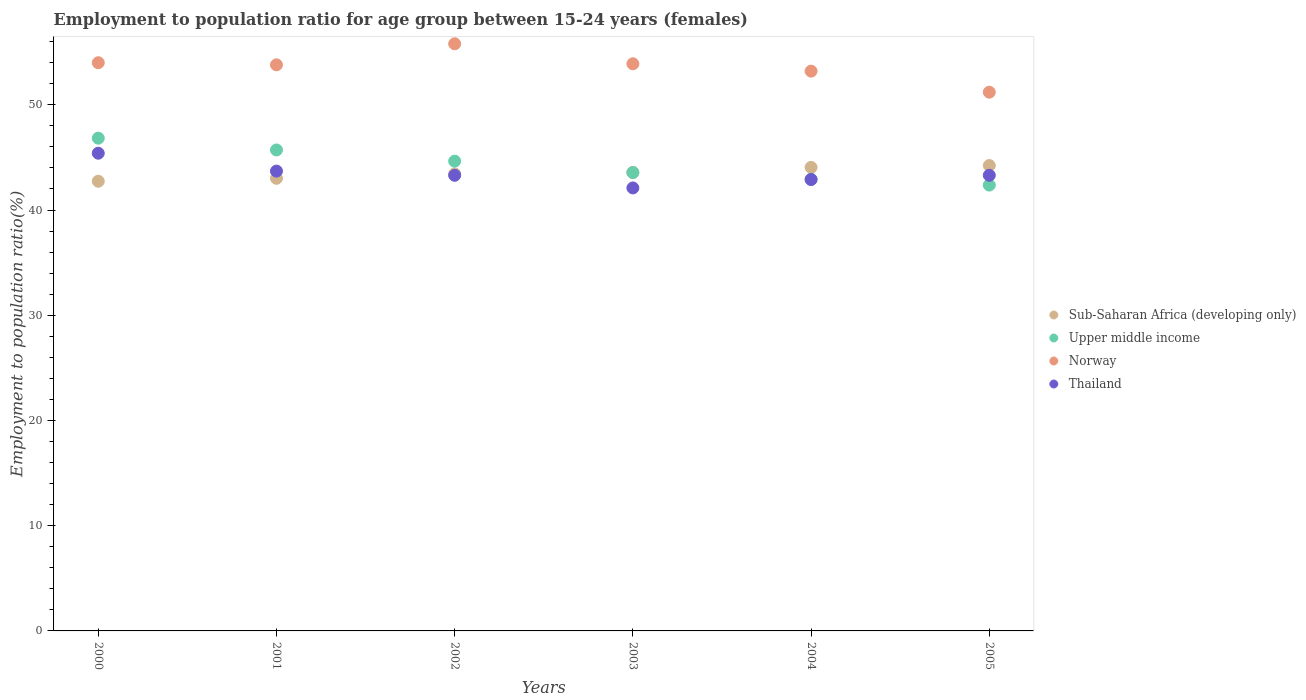What is the employment to population ratio in Sub-Saharan Africa (developing only) in 2003?
Your response must be concise. 43.58. Across all years, what is the maximum employment to population ratio in Norway?
Your answer should be compact. 55.8. Across all years, what is the minimum employment to population ratio in Thailand?
Keep it short and to the point. 42.1. What is the total employment to population ratio in Sub-Saharan Africa (developing only) in the graph?
Make the answer very short. 261.04. What is the difference between the employment to population ratio in Sub-Saharan Africa (developing only) in 2000 and that in 2005?
Keep it short and to the point. -1.49. What is the difference between the employment to population ratio in Norway in 2002 and the employment to population ratio in Upper middle income in 2003?
Offer a very short reply. 12.24. What is the average employment to population ratio in Sub-Saharan Africa (developing only) per year?
Your answer should be compact. 43.51. In the year 2000, what is the difference between the employment to population ratio in Upper middle income and employment to population ratio in Sub-Saharan Africa (developing only)?
Offer a terse response. 4.09. In how many years, is the employment to population ratio in Upper middle income greater than 8 %?
Your answer should be compact. 6. What is the ratio of the employment to population ratio in Thailand in 2003 to that in 2004?
Your response must be concise. 0.98. Is the difference between the employment to population ratio in Upper middle income in 2003 and 2004 greater than the difference between the employment to population ratio in Sub-Saharan Africa (developing only) in 2003 and 2004?
Your response must be concise. Yes. What is the difference between the highest and the second highest employment to population ratio in Norway?
Give a very brief answer. 1.8. What is the difference between the highest and the lowest employment to population ratio in Thailand?
Your answer should be very brief. 3.3. Is it the case that in every year, the sum of the employment to population ratio in Sub-Saharan Africa (developing only) and employment to population ratio in Norway  is greater than the employment to population ratio in Upper middle income?
Provide a short and direct response. Yes. Is the employment to population ratio in Upper middle income strictly greater than the employment to population ratio in Norway over the years?
Give a very brief answer. No. Is the employment to population ratio in Norway strictly less than the employment to population ratio in Sub-Saharan Africa (developing only) over the years?
Ensure brevity in your answer.  No. What is the difference between two consecutive major ticks on the Y-axis?
Provide a succinct answer. 10. Are the values on the major ticks of Y-axis written in scientific E-notation?
Keep it short and to the point. No. Does the graph contain any zero values?
Keep it short and to the point. No. Does the graph contain grids?
Your answer should be compact. No. Where does the legend appear in the graph?
Offer a terse response. Center right. What is the title of the graph?
Make the answer very short. Employment to population ratio for age group between 15-24 years (females). What is the label or title of the X-axis?
Provide a succinct answer. Years. What is the Employment to population ratio(%) in Sub-Saharan Africa (developing only) in 2000?
Your answer should be very brief. 42.74. What is the Employment to population ratio(%) in Upper middle income in 2000?
Make the answer very short. 46.83. What is the Employment to population ratio(%) of Thailand in 2000?
Give a very brief answer. 45.4. What is the Employment to population ratio(%) in Sub-Saharan Africa (developing only) in 2001?
Provide a short and direct response. 43.01. What is the Employment to population ratio(%) in Upper middle income in 2001?
Ensure brevity in your answer.  45.71. What is the Employment to population ratio(%) in Norway in 2001?
Make the answer very short. 53.8. What is the Employment to population ratio(%) in Thailand in 2001?
Provide a short and direct response. 43.7. What is the Employment to population ratio(%) in Sub-Saharan Africa (developing only) in 2002?
Provide a short and direct response. 43.43. What is the Employment to population ratio(%) of Upper middle income in 2002?
Your answer should be compact. 44.65. What is the Employment to population ratio(%) of Norway in 2002?
Offer a very short reply. 55.8. What is the Employment to population ratio(%) of Thailand in 2002?
Ensure brevity in your answer.  43.3. What is the Employment to population ratio(%) of Sub-Saharan Africa (developing only) in 2003?
Offer a terse response. 43.58. What is the Employment to population ratio(%) of Upper middle income in 2003?
Offer a terse response. 43.56. What is the Employment to population ratio(%) in Norway in 2003?
Make the answer very short. 53.9. What is the Employment to population ratio(%) in Thailand in 2003?
Make the answer very short. 42.1. What is the Employment to population ratio(%) of Sub-Saharan Africa (developing only) in 2004?
Offer a very short reply. 44.05. What is the Employment to population ratio(%) of Upper middle income in 2004?
Ensure brevity in your answer.  42.92. What is the Employment to population ratio(%) of Norway in 2004?
Your response must be concise. 53.2. What is the Employment to population ratio(%) of Thailand in 2004?
Your answer should be very brief. 42.9. What is the Employment to population ratio(%) in Sub-Saharan Africa (developing only) in 2005?
Provide a short and direct response. 44.23. What is the Employment to population ratio(%) of Upper middle income in 2005?
Keep it short and to the point. 42.37. What is the Employment to population ratio(%) in Norway in 2005?
Your answer should be compact. 51.2. What is the Employment to population ratio(%) of Thailand in 2005?
Your answer should be compact. 43.3. Across all years, what is the maximum Employment to population ratio(%) in Sub-Saharan Africa (developing only)?
Ensure brevity in your answer.  44.23. Across all years, what is the maximum Employment to population ratio(%) in Upper middle income?
Ensure brevity in your answer.  46.83. Across all years, what is the maximum Employment to population ratio(%) in Norway?
Your response must be concise. 55.8. Across all years, what is the maximum Employment to population ratio(%) of Thailand?
Provide a short and direct response. 45.4. Across all years, what is the minimum Employment to population ratio(%) of Sub-Saharan Africa (developing only)?
Your answer should be compact. 42.74. Across all years, what is the minimum Employment to population ratio(%) of Upper middle income?
Your response must be concise. 42.37. Across all years, what is the minimum Employment to population ratio(%) in Norway?
Offer a very short reply. 51.2. Across all years, what is the minimum Employment to population ratio(%) of Thailand?
Offer a very short reply. 42.1. What is the total Employment to population ratio(%) of Sub-Saharan Africa (developing only) in the graph?
Your answer should be very brief. 261.04. What is the total Employment to population ratio(%) of Upper middle income in the graph?
Provide a short and direct response. 266.04. What is the total Employment to population ratio(%) in Norway in the graph?
Make the answer very short. 321.9. What is the total Employment to population ratio(%) in Thailand in the graph?
Make the answer very short. 260.7. What is the difference between the Employment to population ratio(%) of Sub-Saharan Africa (developing only) in 2000 and that in 2001?
Ensure brevity in your answer.  -0.28. What is the difference between the Employment to population ratio(%) of Upper middle income in 2000 and that in 2001?
Give a very brief answer. 1.12. What is the difference between the Employment to population ratio(%) of Sub-Saharan Africa (developing only) in 2000 and that in 2002?
Provide a succinct answer. -0.7. What is the difference between the Employment to population ratio(%) in Upper middle income in 2000 and that in 2002?
Keep it short and to the point. 2.18. What is the difference between the Employment to population ratio(%) of Thailand in 2000 and that in 2002?
Provide a succinct answer. 2.1. What is the difference between the Employment to population ratio(%) in Sub-Saharan Africa (developing only) in 2000 and that in 2003?
Your response must be concise. -0.84. What is the difference between the Employment to population ratio(%) in Upper middle income in 2000 and that in 2003?
Your answer should be compact. 3.27. What is the difference between the Employment to population ratio(%) in Sub-Saharan Africa (developing only) in 2000 and that in 2004?
Provide a succinct answer. -1.32. What is the difference between the Employment to population ratio(%) in Upper middle income in 2000 and that in 2004?
Your answer should be compact. 3.91. What is the difference between the Employment to population ratio(%) in Sub-Saharan Africa (developing only) in 2000 and that in 2005?
Provide a short and direct response. -1.49. What is the difference between the Employment to population ratio(%) of Upper middle income in 2000 and that in 2005?
Offer a terse response. 4.46. What is the difference between the Employment to population ratio(%) in Sub-Saharan Africa (developing only) in 2001 and that in 2002?
Offer a very short reply. -0.42. What is the difference between the Employment to population ratio(%) of Upper middle income in 2001 and that in 2002?
Offer a terse response. 1.06. What is the difference between the Employment to population ratio(%) of Sub-Saharan Africa (developing only) in 2001 and that in 2003?
Offer a terse response. -0.56. What is the difference between the Employment to population ratio(%) of Upper middle income in 2001 and that in 2003?
Provide a short and direct response. 2.14. What is the difference between the Employment to population ratio(%) of Sub-Saharan Africa (developing only) in 2001 and that in 2004?
Provide a succinct answer. -1.04. What is the difference between the Employment to population ratio(%) in Upper middle income in 2001 and that in 2004?
Give a very brief answer. 2.78. What is the difference between the Employment to population ratio(%) of Norway in 2001 and that in 2004?
Provide a short and direct response. 0.6. What is the difference between the Employment to population ratio(%) in Sub-Saharan Africa (developing only) in 2001 and that in 2005?
Keep it short and to the point. -1.21. What is the difference between the Employment to population ratio(%) in Upper middle income in 2001 and that in 2005?
Keep it short and to the point. 3.34. What is the difference between the Employment to population ratio(%) in Sub-Saharan Africa (developing only) in 2002 and that in 2003?
Your answer should be very brief. -0.14. What is the difference between the Employment to population ratio(%) in Upper middle income in 2002 and that in 2003?
Ensure brevity in your answer.  1.08. What is the difference between the Employment to population ratio(%) in Norway in 2002 and that in 2003?
Make the answer very short. 1.9. What is the difference between the Employment to population ratio(%) in Sub-Saharan Africa (developing only) in 2002 and that in 2004?
Keep it short and to the point. -0.62. What is the difference between the Employment to population ratio(%) of Upper middle income in 2002 and that in 2004?
Provide a short and direct response. 1.72. What is the difference between the Employment to population ratio(%) of Norway in 2002 and that in 2004?
Ensure brevity in your answer.  2.6. What is the difference between the Employment to population ratio(%) in Sub-Saharan Africa (developing only) in 2002 and that in 2005?
Provide a short and direct response. -0.79. What is the difference between the Employment to population ratio(%) of Upper middle income in 2002 and that in 2005?
Make the answer very short. 2.27. What is the difference between the Employment to population ratio(%) in Thailand in 2002 and that in 2005?
Ensure brevity in your answer.  0. What is the difference between the Employment to population ratio(%) of Sub-Saharan Africa (developing only) in 2003 and that in 2004?
Keep it short and to the point. -0.48. What is the difference between the Employment to population ratio(%) of Upper middle income in 2003 and that in 2004?
Provide a short and direct response. 0.64. What is the difference between the Employment to population ratio(%) of Norway in 2003 and that in 2004?
Your answer should be very brief. 0.7. What is the difference between the Employment to population ratio(%) of Sub-Saharan Africa (developing only) in 2003 and that in 2005?
Provide a succinct answer. -0.65. What is the difference between the Employment to population ratio(%) in Upper middle income in 2003 and that in 2005?
Offer a terse response. 1.19. What is the difference between the Employment to population ratio(%) in Norway in 2003 and that in 2005?
Ensure brevity in your answer.  2.7. What is the difference between the Employment to population ratio(%) in Sub-Saharan Africa (developing only) in 2004 and that in 2005?
Your answer should be very brief. -0.17. What is the difference between the Employment to population ratio(%) in Upper middle income in 2004 and that in 2005?
Ensure brevity in your answer.  0.55. What is the difference between the Employment to population ratio(%) in Norway in 2004 and that in 2005?
Your answer should be very brief. 2. What is the difference between the Employment to population ratio(%) in Thailand in 2004 and that in 2005?
Ensure brevity in your answer.  -0.4. What is the difference between the Employment to population ratio(%) of Sub-Saharan Africa (developing only) in 2000 and the Employment to population ratio(%) of Upper middle income in 2001?
Your response must be concise. -2.97. What is the difference between the Employment to population ratio(%) of Sub-Saharan Africa (developing only) in 2000 and the Employment to population ratio(%) of Norway in 2001?
Your answer should be very brief. -11.06. What is the difference between the Employment to population ratio(%) of Sub-Saharan Africa (developing only) in 2000 and the Employment to population ratio(%) of Thailand in 2001?
Ensure brevity in your answer.  -0.96. What is the difference between the Employment to population ratio(%) of Upper middle income in 2000 and the Employment to population ratio(%) of Norway in 2001?
Your response must be concise. -6.97. What is the difference between the Employment to population ratio(%) in Upper middle income in 2000 and the Employment to population ratio(%) in Thailand in 2001?
Your answer should be compact. 3.13. What is the difference between the Employment to population ratio(%) in Norway in 2000 and the Employment to population ratio(%) in Thailand in 2001?
Offer a terse response. 10.3. What is the difference between the Employment to population ratio(%) of Sub-Saharan Africa (developing only) in 2000 and the Employment to population ratio(%) of Upper middle income in 2002?
Offer a terse response. -1.91. What is the difference between the Employment to population ratio(%) of Sub-Saharan Africa (developing only) in 2000 and the Employment to population ratio(%) of Norway in 2002?
Give a very brief answer. -13.06. What is the difference between the Employment to population ratio(%) of Sub-Saharan Africa (developing only) in 2000 and the Employment to population ratio(%) of Thailand in 2002?
Offer a very short reply. -0.56. What is the difference between the Employment to population ratio(%) in Upper middle income in 2000 and the Employment to population ratio(%) in Norway in 2002?
Offer a terse response. -8.97. What is the difference between the Employment to population ratio(%) in Upper middle income in 2000 and the Employment to population ratio(%) in Thailand in 2002?
Ensure brevity in your answer.  3.53. What is the difference between the Employment to population ratio(%) in Norway in 2000 and the Employment to population ratio(%) in Thailand in 2002?
Offer a terse response. 10.7. What is the difference between the Employment to population ratio(%) of Sub-Saharan Africa (developing only) in 2000 and the Employment to population ratio(%) of Upper middle income in 2003?
Keep it short and to the point. -0.83. What is the difference between the Employment to population ratio(%) of Sub-Saharan Africa (developing only) in 2000 and the Employment to population ratio(%) of Norway in 2003?
Keep it short and to the point. -11.16. What is the difference between the Employment to population ratio(%) in Sub-Saharan Africa (developing only) in 2000 and the Employment to population ratio(%) in Thailand in 2003?
Offer a very short reply. 0.64. What is the difference between the Employment to population ratio(%) of Upper middle income in 2000 and the Employment to population ratio(%) of Norway in 2003?
Give a very brief answer. -7.07. What is the difference between the Employment to population ratio(%) in Upper middle income in 2000 and the Employment to population ratio(%) in Thailand in 2003?
Provide a short and direct response. 4.73. What is the difference between the Employment to population ratio(%) in Sub-Saharan Africa (developing only) in 2000 and the Employment to population ratio(%) in Upper middle income in 2004?
Your response must be concise. -0.19. What is the difference between the Employment to population ratio(%) in Sub-Saharan Africa (developing only) in 2000 and the Employment to population ratio(%) in Norway in 2004?
Your answer should be compact. -10.46. What is the difference between the Employment to population ratio(%) of Sub-Saharan Africa (developing only) in 2000 and the Employment to population ratio(%) of Thailand in 2004?
Offer a very short reply. -0.16. What is the difference between the Employment to population ratio(%) of Upper middle income in 2000 and the Employment to population ratio(%) of Norway in 2004?
Give a very brief answer. -6.37. What is the difference between the Employment to population ratio(%) of Upper middle income in 2000 and the Employment to population ratio(%) of Thailand in 2004?
Provide a short and direct response. 3.93. What is the difference between the Employment to population ratio(%) in Sub-Saharan Africa (developing only) in 2000 and the Employment to population ratio(%) in Upper middle income in 2005?
Keep it short and to the point. 0.37. What is the difference between the Employment to population ratio(%) in Sub-Saharan Africa (developing only) in 2000 and the Employment to population ratio(%) in Norway in 2005?
Ensure brevity in your answer.  -8.46. What is the difference between the Employment to population ratio(%) of Sub-Saharan Africa (developing only) in 2000 and the Employment to population ratio(%) of Thailand in 2005?
Your answer should be very brief. -0.56. What is the difference between the Employment to population ratio(%) in Upper middle income in 2000 and the Employment to population ratio(%) in Norway in 2005?
Provide a succinct answer. -4.37. What is the difference between the Employment to population ratio(%) of Upper middle income in 2000 and the Employment to population ratio(%) of Thailand in 2005?
Offer a terse response. 3.53. What is the difference between the Employment to population ratio(%) of Norway in 2000 and the Employment to population ratio(%) of Thailand in 2005?
Ensure brevity in your answer.  10.7. What is the difference between the Employment to population ratio(%) of Sub-Saharan Africa (developing only) in 2001 and the Employment to population ratio(%) of Upper middle income in 2002?
Offer a very short reply. -1.63. What is the difference between the Employment to population ratio(%) in Sub-Saharan Africa (developing only) in 2001 and the Employment to population ratio(%) in Norway in 2002?
Your answer should be very brief. -12.79. What is the difference between the Employment to population ratio(%) in Sub-Saharan Africa (developing only) in 2001 and the Employment to population ratio(%) in Thailand in 2002?
Offer a very short reply. -0.29. What is the difference between the Employment to population ratio(%) in Upper middle income in 2001 and the Employment to population ratio(%) in Norway in 2002?
Give a very brief answer. -10.09. What is the difference between the Employment to population ratio(%) in Upper middle income in 2001 and the Employment to population ratio(%) in Thailand in 2002?
Offer a terse response. 2.41. What is the difference between the Employment to population ratio(%) in Norway in 2001 and the Employment to population ratio(%) in Thailand in 2002?
Ensure brevity in your answer.  10.5. What is the difference between the Employment to population ratio(%) of Sub-Saharan Africa (developing only) in 2001 and the Employment to population ratio(%) of Upper middle income in 2003?
Offer a terse response. -0.55. What is the difference between the Employment to population ratio(%) in Sub-Saharan Africa (developing only) in 2001 and the Employment to population ratio(%) in Norway in 2003?
Your answer should be compact. -10.89. What is the difference between the Employment to population ratio(%) of Sub-Saharan Africa (developing only) in 2001 and the Employment to population ratio(%) of Thailand in 2003?
Offer a terse response. 0.91. What is the difference between the Employment to population ratio(%) in Upper middle income in 2001 and the Employment to population ratio(%) in Norway in 2003?
Your answer should be very brief. -8.19. What is the difference between the Employment to population ratio(%) of Upper middle income in 2001 and the Employment to population ratio(%) of Thailand in 2003?
Ensure brevity in your answer.  3.61. What is the difference between the Employment to population ratio(%) of Sub-Saharan Africa (developing only) in 2001 and the Employment to population ratio(%) of Upper middle income in 2004?
Ensure brevity in your answer.  0.09. What is the difference between the Employment to population ratio(%) in Sub-Saharan Africa (developing only) in 2001 and the Employment to population ratio(%) in Norway in 2004?
Your answer should be very brief. -10.19. What is the difference between the Employment to population ratio(%) of Sub-Saharan Africa (developing only) in 2001 and the Employment to population ratio(%) of Thailand in 2004?
Give a very brief answer. 0.11. What is the difference between the Employment to population ratio(%) in Upper middle income in 2001 and the Employment to population ratio(%) in Norway in 2004?
Provide a succinct answer. -7.49. What is the difference between the Employment to population ratio(%) of Upper middle income in 2001 and the Employment to population ratio(%) of Thailand in 2004?
Provide a short and direct response. 2.81. What is the difference between the Employment to population ratio(%) in Norway in 2001 and the Employment to population ratio(%) in Thailand in 2004?
Offer a terse response. 10.9. What is the difference between the Employment to population ratio(%) in Sub-Saharan Africa (developing only) in 2001 and the Employment to population ratio(%) in Upper middle income in 2005?
Make the answer very short. 0.64. What is the difference between the Employment to population ratio(%) in Sub-Saharan Africa (developing only) in 2001 and the Employment to population ratio(%) in Norway in 2005?
Keep it short and to the point. -8.19. What is the difference between the Employment to population ratio(%) in Sub-Saharan Africa (developing only) in 2001 and the Employment to population ratio(%) in Thailand in 2005?
Your answer should be compact. -0.29. What is the difference between the Employment to population ratio(%) of Upper middle income in 2001 and the Employment to population ratio(%) of Norway in 2005?
Ensure brevity in your answer.  -5.49. What is the difference between the Employment to population ratio(%) in Upper middle income in 2001 and the Employment to population ratio(%) in Thailand in 2005?
Ensure brevity in your answer.  2.41. What is the difference between the Employment to population ratio(%) of Sub-Saharan Africa (developing only) in 2002 and the Employment to population ratio(%) of Upper middle income in 2003?
Offer a terse response. -0.13. What is the difference between the Employment to population ratio(%) of Sub-Saharan Africa (developing only) in 2002 and the Employment to population ratio(%) of Norway in 2003?
Keep it short and to the point. -10.47. What is the difference between the Employment to population ratio(%) of Sub-Saharan Africa (developing only) in 2002 and the Employment to population ratio(%) of Thailand in 2003?
Offer a very short reply. 1.33. What is the difference between the Employment to population ratio(%) in Upper middle income in 2002 and the Employment to population ratio(%) in Norway in 2003?
Make the answer very short. -9.25. What is the difference between the Employment to population ratio(%) of Upper middle income in 2002 and the Employment to population ratio(%) of Thailand in 2003?
Ensure brevity in your answer.  2.55. What is the difference between the Employment to population ratio(%) in Norway in 2002 and the Employment to population ratio(%) in Thailand in 2003?
Provide a succinct answer. 13.7. What is the difference between the Employment to population ratio(%) in Sub-Saharan Africa (developing only) in 2002 and the Employment to population ratio(%) in Upper middle income in 2004?
Provide a short and direct response. 0.51. What is the difference between the Employment to population ratio(%) in Sub-Saharan Africa (developing only) in 2002 and the Employment to population ratio(%) in Norway in 2004?
Ensure brevity in your answer.  -9.77. What is the difference between the Employment to population ratio(%) in Sub-Saharan Africa (developing only) in 2002 and the Employment to population ratio(%) in Thailand in 2004?
Your answer should be compact. 0.53. What is the difference between the Employment to population ratio(%) in Upper middle income in 2002 and the Employment to population ratio(%) in Norway in 2004?
Keep it short and to the point. -8.55. What is the difference between the Employment to population ratio(%) in Upper middle income in 2002 and the Employment to population ratio(%) in Thailand in 2004?
Ensure brevity in your answer.  1.75. What is the difference between the Employment to population ratio(%) in Norway in 2002 and the Employment to population ratio(%) in Thailand in 2004?
Offer a terse response. 12.9. What is the difference between the Employment to population ratio(%) in Sub-Saharan Africa (developing only) in 2002 and the Employment to population ratio(%) in Upper middle income in 2005?
Offer a very short reply. 1.06. What is the difference between the Employment to population ratio(%) in Sub-Saharan Africa (developing only) in 2002 and the Employment to population ratio(%) in Norway in 2005?
Ensure brevity in your answer.  -7.77. What is the difference between the Employment to population ratio(%) of Sub-Saharan Africa (developing only) in 2002 and the Employment to population ratio(%) of Thailand in 2005?
Give a very brief answer. 0.13. What is the difference between the Employment to population ratio(%) in Upper middle income in 2002 and the Employment to population ratio(%) in Norway in 2005?
Give a very brief answer. -6.55. What is the difference between the Employment to population ratio(%) of Upper middle income in 2002 and the Employment to population ratio(%) of Thailand in 2005?
Your response must be concise. 1.35. What is the difference between the Employment to population ratio(%) in Sub-Saharan Africa (developing only) in 2003 and the Employment to population ratio(%) in Upper middle income in 2004?
Give a very brief answer. 0.65. What is the difference between the Employment to population ratio(%) of Sub-Saharan Africa (developing only) in 2003 and the Employment to population ratio(%) of Norway in 2004?
Make the answer very short. -9.62. What is the difference between the Employment to population ratio(%) of Sub-Saharan Africa (developing only) in 2003 and the Employment to population ratio(%) of Thailand in 2004?
Offer a terse response. 0.68. What is the difference between the Employment to population ratio(%) in Upper middle income in 2003 and the Employment to population ratio(%) in Norway in 2004?
Provide a succinct answer. -9.64. What is the difference between the Employment to population ratio(%) of Upper middle income in 2003 and the Employment to population ratio(%) of Thailand in 2004?
Ensure brevity in your answer.  0.66. What is the difference between the Employment to population ratio(%) of Sub-Saharan Africa (developing only) in 2003 and the Employment to population ratio(%) of Upper middle income in 2005?
Provide a short and direct response. 1.2. What is the difference between the Employment to population ratio(%) of Sub-Saharan Africa (developing only) in 2003 and the Employment to population ratio(%) of Norway in 2005?
Provide a short and direct response. -7.62. What is the difference between the Employment to population ratio(%) in Sub-Saharan Africa (developing only) in 2003 and the Employment to population ratio(%) in Thailand in 2005?
Ensure brevity in your answer.  0.28. What is the difference between the Employment to population ratio(%) in Upper middle income in 2003 and the Employment to population ratio(%) in Norway in 2005?
Ensure brevity in your answer.  -7.64. What is the difference between the Employment to population ratio(%) of Upper middle income in 2003 and the Employment to population ratio(%) of Thailand in 2005?
Provide a short and direct response. 0.26. What is the difference between the Employment to population ratio(%) in Norway in 2003 and the Employment to population ratio(%) in Thailand in 2005?
Offer a terse response. 10.6. What is the difference between the Employment to population ratio(%) in Sub-Saharan Africa (developing only) in 2004 and the Employment to population ratio(%) in Upper middle income in 2005?
Give a very brief answer. 1.68. What is the difference between the Employment to population ratio(%) of Sub-Saharan Africa (developing only) in 2004 and the Employment to population ratio(%) of Norway in 2005?
Give a very brief answer. -7.15. What is the difference between the Employment to population ratio(%) of Sub-Saharan Africa (developing only) in 2004 and the Employment to population ratio(%) of Thailand in 2005?
Provide a succinct answer. 0.75. What is the difference between the Employment to population ratio(%) in Upper middle income in 2004 and the Employment to population ratio(%) in Norway in 2005?
Give a very brief answer. -8.28. What is the difference between the Employment to population ratio(%) in Upper middle income in 2004 and the Employment to population ratio(%) in Thailand in 2005?
Make the answer very short. -0.38. What is the difference between the Employment to population ratio(%) in Norway in 2004 and the Employment to population ratio(%) in Thailand in 2005?
Provide a short and direct response. 9.9. What is the average Employment to population ratio(%) of Sub-Saharan Africa (developing only) per year?
Your answer should be very brief. 43.51. What is the average Employment to population ratio(%) of Upper middle income per year?
Provide a short and direct response. 44.34. What is the average Employment to population ratio(%) in Norway per year?
Make the answer very short. 53.65. What is the average Employment to population ratio(%) in Thailand per year?
Your answer should be very brief. 43.45. In the year 2000, what is the difference between the Employment to population ratio(%) of Sub-Saharan Africa (developing only) and Employment to population ratio(%) of Upper middle income?
Provide a succinct answer. -4.09. In the year 2000, what is the difference between the Employment to population ratio(%) of Sub-Saharan Africa (developing only) and Employment to population ratio(%) of Norway?
Keep it short and to the point. -11.26. In the year 2000, what is the difference between the Employment to population ratio(%) of Sub-Saharan Africa (developing only) and Employment to population ratio(%) of Thailand?
Keep it short and to the point. -2.66. In the year 2000, what is the difference between the Employment to population ratio(%) in Upper middle income and Employment to population ratio(%) in Norway?
Keep it short and to the point. -7.17. In the year 2000, what is the difference between the Employment to population ratio(%) in Upper middle income and Employment to population ratio(%) in Thailand?
Provide a succinct answer. 1.43. In the year 2000, what is the difference between the Employment to population ratio(%) of Norway and Employment to population ratio(%) of Thailand?
Make the answer very short. 8.6. In the year 2001, what is the difference between the Employment to population ratio(%) of Sub-Saharan Africa (developing only) and Employment to population ratio(%) of Upper middle income?
Your response must be concise. -2.69. In the year 2001, what is the difference between the Employment to population ratio(%) in Sub-Saharan Africa (developing only) and Employment to population ratio(%) in Norway?
Your answer should be compact. -10.79. In the year 2001, what is the difference between the Employment to population ratio(%) in Sub-Saharan Africa (developing only) and Employment to population ratio(%) in Thailand?
Your response must be concise. -0.69. In the year 2001, what is the difference between the Employment to population ratio(%) of Upper middle income and Employment to population ratio(%) of Norway?
Make the answer very short. -8.09. In the year 2001, what is the difference between the Employment to population ratio(%) in Upper middle income and Employment to population ratio(%) in Thailand?
Provide a succinct answer. 2.01. In the year 2001, what is the difference between the Employment to population ratio(%) in Norway and Employment to population ratio(%) in Thailand?
Give a very brief answer. 10.1. In the year 2002, what is the difference between the Employment to population ratio(%) of Sub-Saharan Africa (developing only) and Employment to population ratio(%) of Upper middle income?
Provide a succinct answer. -1.21. In the year 2002, what is the difference between the Employment to population ratio(%) of Sub-Saharan Africa (developing only) and Employment to population ratio(%) of Norway?
Provide a short and direct response. -12.37. In the year 2002, what is the difference between the Employment to population ratio(%) of Sub-Saharan Africa (developing only) and Employment to population ratio(%) of Thailand?
Ensure brevity in your answer.  0.13. In the year 2002, what is the difference between the Employment to population ratio(%) in Upper middle income and Employment to population ratio(%) in Norway?
Make the answer very short. -11.15. In the year 2002, what is the difference between the Employment to population ratio(%) of Upper middle income and Employment to population ratio(%) of Thailand?
Provide a short and direct response. 1.35. In the year 2003, what is the difference between the Employment to population ratio(%) of Sub-Saharan Africa (developing only) and Employment to population ratio(%) of Upper middle income?
Your answer should be compact. 0.01. In the year 2003, what is the difference between the Employment to population ratio(%) in Sub-Saharan Africa (developing only) and Employment to population ratio(%) in Norway?
Your answer should be compact. -10.32. In the year 2003, what is the difference between the Employment to population ratio(%) of Sub-Saharan Africa (developing only) and Employment to population ratio(%) of Thailand?
Ensure brevity in your answer.  1.48. In the year 2003, what is the difference between the Employment to population ratio(%) in Upper middle income and Employment to population ratio(%) in Norway?
Provide a short and direct response. -10.34. In the year 2003, what is the difference between the Employment to population ratio(%) in Upper middle income and Employment to population ratio(%) in Thailand?
Your answer should be very brief. 1.46. In the year 2003, what is the difference between the Employment to population ratio(%) of Norway and Employment to population ratio(%) of Thailand?
Give a very brief answer. 11.8. In the year 2004, what is the difference between the Employment to population ratio(%) in Sub-Saharan Africa (developing only) and Employment to population ratio(%) in Upper middle income?
Provide a succinct answer. 1.13. In the year 2004, what is the difference between the Employment to population ratio(%) of Sub-Saharan Africa (developing only) and Employment to population ratio(%) of Norway?
Give a very brief answer. -9.15. In the year 2004, what is the difference between the Employment to population ratio(%) in Sub-Saharan Africa (developing only) and Employment to population ratio(%) in Thailand?
Your response must be concise. 1.15. In the year 2004, what is the difference between the Employment to population ratio(%) in Upper middle income and Employment to population ratio(%) in Norway?
Make the answer very short. -10.28. In the year 2004, what is the difference between the Employment to population ratio(%) in Upper middle income and Employment to population ratio(%) in Thailand?
Give a very brief answer. 0.02. In the year 2004, what is the difference between the Employment to population ratio(%) of Norway and Employment to population ratio(%) of Thailand?
Your answer should be very brief. 10.3. In the year 2005, what is the difference between the Employment to population ratio(%) in Sub-Saharan Africa (developing only) and Employment to population ratio(%) in Upper middle income?
Provide a short and direct response. 1.86. In the year 2005, what is the difference between the Employment to population ratio(%) of Sub-Saharan Africa (developing only) and Employment to population ratio(%) of Norway?
Ensure brevity in your answer.  -6.97. In the year 2005, what is the difference between the Employment to population ratio(%) in Sub-Saharan Africa (developing only) and Employment to population ratio(%) in Thailand?
Your response must be concise. 0.93. In the year 2005, what is the difference between the Employment to population ratio(%) of Upper middle income and Employment to population ratio(%) of Norway?
Provide a succinct answer. -8.83. In the year 2005, what is the difference between the Employment to population ratio(%) of Upper middle income and Employment to population ratio(%) of Thailand?
Give a very brief answer. -0.93. In the year 2005, what is the difference between the Employment to population ratio(%) in Norway and Employment to population ratio(%) in Thailand?
Keep it short and to the point. 7.9. What is the ratio of the Employment to population ratio(%) in Upper middle income in 2000 to that in 2001?
Ensure brevity in your answer.  1.02. What is the ratio of the Employment to population ratio(%) in Thailand in 2000 to that in 2001?
Offer a very short reply. 1.04. What is the ratio of the Employment to population ratio(%) in Sub-Saharan Africa (developing only) in 2000 to that in 2002?
Give a very brief answer. 0.98. What is the ratio of the Employment to population ratio(%) in Upper middle income in 2000 to that in 2002?
Offer a terse response. 1.05. What is the ratio of the Employment to population ratio(%) in Thailand in 2000 to that in 2002?
Your response must be concise. 1.05. What is the ratio of the Employment to population ratio(%) of Sub-Saharan Africa (developing only) in 2000 to that in 2003?
Offer a very short reply. 0.98. What is the ratio of the Employment to population ratio(%) of Upper middle income in 2000 to that in 2003?
Your answer should be very brief. 1.07. What is the ratio of the Employment to population ratio(%) in Norway in 2000 to that in 2003?
Provide a short and direct response. 1. What is the ratio of the Employment to population ratio(%) of Thailand in 2000 to that in 2003?
Make the answer very short. 1.08. What is the ratio of the Employment to population ratio(%) in Sub-Saharan Africa (developing only) in 2000 to that in 2004?
Offer a very short reply. 0.97. What is the ratio of the Employment to population ratio(%) in Upper middle income in 2000 to that in 2004?
Ensure brevity in your answer.  1.09. What is the ratio of the Employment to population ratio(%) of Thailand in 2000 to that in 2004?
Keep it short and to the point. 1.06. What is the ratio of the Employment to population ratio(%) in Sub-Saharan Africa (developing only) in 2000 to that in 2005?
Ensure brevity in your answer.  0.97. What is the ratio of the Employment to population ratio(%) of Upper middle income in 2000 to that in 2005?
Provide a succinct answer. 1.11. What is the ratio of the Employment to population ratio(%) of Norway in 2000 to that in 2005?
Your response must be concise. 1.05. What is the ratio of the Employment to population ratio(%) of Thailand in 2000 to that in 2005?
Keep it short and to the point. 1.05. What is the ratio of the Employment to population ratio(%) in Sub-Saharan Africa (developing only) in 2001 to that in 2002?
Keep it short and to the point. 0.99. What is the ratio of the Employment to population ratio(%) of Upper middle income in 2001 to that in 2002?
Offer a terse response. 1.02. What is the ratio of the Employment to population ratio(%) in Norway in 2001 to that in 2002?
Your answer should be very brief. 0.96. What is the ratio of the Employment to population ratio(%) of Thailand in 2001 to that in 2002?
Your answer should be very brief. 1.01. What is the ratio of the Employment to population ratio(%) of Sub-Saharan Africa (developing only) in 2001 to that in 2003?
Make the answer very short. 0.99. What is the ratio of the Employment to population ratio(%) in Upper middle income in 2001 to that in 2003?
Offer a very short reply. 1.05. What is the ratio of the Employment to population ratio(%) in Thailand in 2001 to that in 2003?
Ensure brevity in your answer.  1.04. What is the ratio of the Employment to population ratio(%) in Sub-Saharan Africa (developing only) in 2001 to that in 2004?
Provide a succinct answer. 0.98. What is the ratio of the Employment to population ratio(%) of Upper middle income in 2001 to that in 2004?
Provide a short and direct response. 1.06. What is the ratio of the Employment to population ratio(%) in Norway in 2001 to that in 2004?
Give a very brief answer. 1.01. What is the ratio of the Employment to population ratio(%) of Thailand in 2001 to that in 2004?
Ensure brevity in your answer.  1.02. What is the ratio of the Employment to population ratio(%) in Sub-Saharan Africa (developing only) in 2001 to that in 2005?
Give a very brief answer. 0.97. What is the ratio of the Employment to population ratio(%) in Upper middle income in 2001 to that in 2005?
Give a very brief answer. 1.08. What is the ratio of the Employment to population ratio(%) of Norway in 2001 to that in 2005?
Provide a short and direct response. 1.05. What is the ratio of the Employment to population ratio(%) of Thailand in 2001 to that in 2005?
Offer a very short reply. 1.01. What is the ratio of the Employment to population ratio(%) of Upper middle income in 2002 to that in 2003?
Your response must be concise. 1.02. What is the ratio of the Employment to population ratio(%) of Norway in 2002 to that in 2003?
Your response must be concise. 1.04. What is the ratio of the Employment to population ratio(%) of Thailand in 2002 to that in 2003?
Your answer should be compact. 1.03. What is the ratio of the Employment to population ratio(%) in Sub-Saharan Africa (developing only) in 2002 to that in 2004?
Offer a very short reply. 0.99. What is the ratio of the Employment to population ratio(%) of Upper middle income in 2002 to that in 2004?
Your answer should be compact. 1.04. What is the ratio of the Employment to population ratio(%) of Norway in 2002 to that in 2004?
Ensure brevity in your answer.  1.05. What is the ratio of the Employment to population ratio(%) of Thailand in 2002 to that in 2004?
Your answer should be compact. 1.01. What is the ratio of the Employment to population ratio(%) in Sub-Saharan Africa (developing only) in 2002 to that in 2005?
Your answer should be very brief. 0.98. What is the ratio of the Employment to population ratio(%) of Upper middle income in 2002 to that in 2005?
Your answer should be compact. 1.05. What is the ratio of the Employment to population ratio(%) in Norway in 2002 to that in 2005?
Provide a short and direct response. 1.09. What is the ratio of the Employment to population ratio(%) of Upper middle income in 2003 to that in 2004?
Your answer should be very brief. 1.01. What is the ratio of the Employment to population ratio(%) of Norway in 2003 to that in 2004?
Your answer should be very brief. 1.01. What is the ratio of the Employment to population ratio(%) of Thailand in 2003 to that in 2004?
Give a very brief answer. 0.98. What is the ratio of the Employment to population ratio(%) of Sub-Saharan Africa (developing only) in 2003 to that in 2005?
Give a very brief answer. 0.99. What is the ratio of the Employment to population ratio(%) in Upper middle income in 2003 to that in 2005?
Your response must be concise. 1.03. What is the ratio of the Employment to population ratio(%) in Norway in 2003 to that in 2005?
Offer a very short reply. 1.05. What is the ratio of the Employment to population ratio(%) of Thailand in 2003 to that in 2005?
Offer a very short reply. 0.97. What is the ratio of the Employment to population ratio(%) of Upper middle income in 2004 to that in 2005?
Ensure brevity in your answer.  1.01. What is the ratio of the Employment to population ratio(%) in Norway in 2004 to that in 2005?
Offer a terse response. 1.04. What is the difference between the highest and the second highest Employment to population ratio(%) of Sub-Saharan Africa (developing only)?
Give a very brief answer. 0.17. What is the difference between the highest and the second highest Employment to population ratio(%) of Upper middle income?
Your answer should be compact. 1.12. What is the difference between the highest and the second highest Employment to population ratio(%) of Norway?
Ensure brevity in your answer.  1.8. What is the difference between the highest and the second highest Employment to population ratio(%) of Thailand?
Make the answer very short. 1.7. What is the difference between the highest and the lowest Employment to population ratio(%) of Sub-Saharan Africa (developing only)?
Ensure brevity in your answer.  1.49. What is the difference between the highest and the lowest Employment to population ratio(%) in Upper middle income?
Keep it short and to the point. 4.46. What is the difference between the highest and the lowest Employment to population ratio(%) in Thailand?
Offer a terse response. 3.3. 